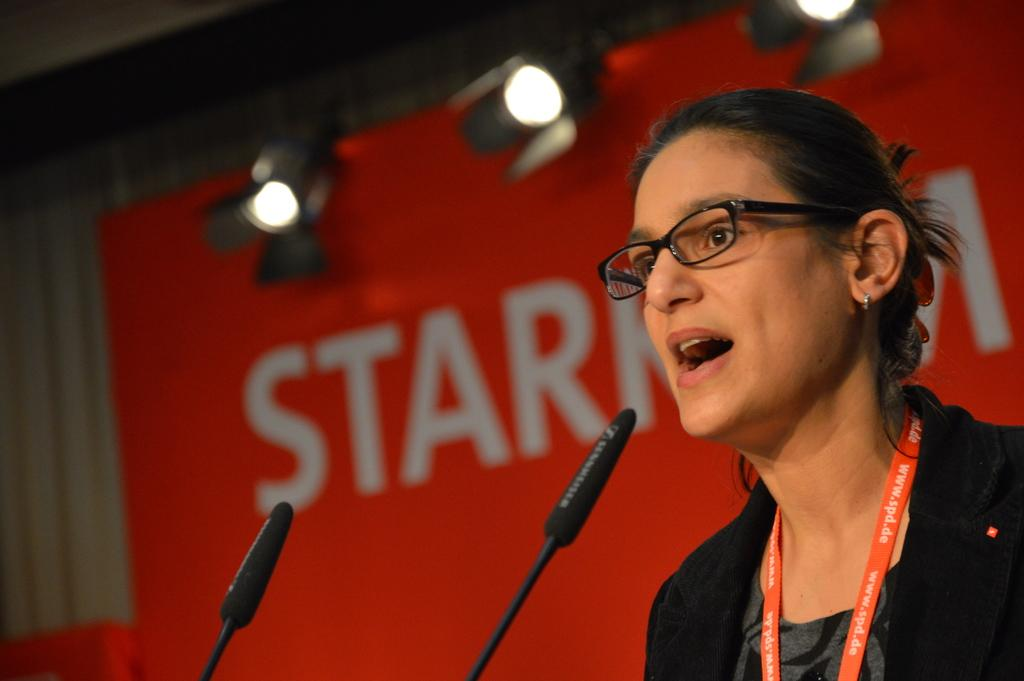What objects are located at the bottom of the image? There are two microphones at the bottom of the image. What is the woman in the image doing? The woman is standing and talking in the bottom right corner of the image. What can be seen behind the woman? There is a banner visible behind the woman. What type of illumination is present in the image? Lights are present in the image. What type of wound can be seen on the woman's arm in the image? There is no wound visible on the woman's arm in the image. What type of metal is used to construct the microphones in the image? The image does not provide information about the type of metal used to construct the microphones. 